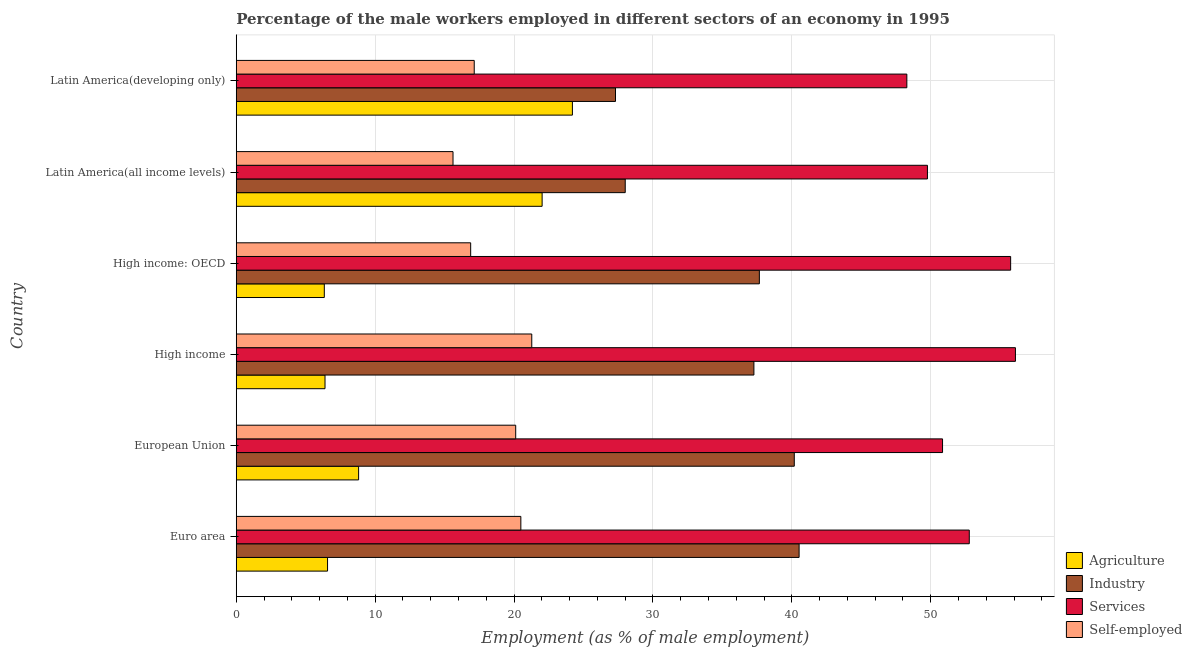Are the number of bars per tick equal to the number of legend labels?
Make the answer very short. Yes. Are the number of bars on each tick of the Y-axis equal?
Keep it short and to the point. Yes. How many bars are there on the 2nd tick from the top?
Give a very brief answer. 4. What is the label of the 1st group of bars from the top?
Your answer should be very brief. Latin America(developing only). In how many cases, is the number of bars for a given country not equal to the number of legend labels?
Your answer should be very brief. 0. What is the percentage of male workers in services in High income: OECD?
Your response must be concise. 55.76. Across all countries, what is the maximum percentage of self employed male workers?
Make the answer very short. 21.28. Across all countries, what is the minimum percentage of male workers in industry?
Give a very brief answer. 27.31. In which country was the percentage of male workers in industry maximum?
Your response must be concise. Euro area. In which country was the percentage of self employed male workers minimum?
Your answer should be very brief. Latin America(all income levels). What is the total percentage of male workers in services in the graph?
Keep it short and to the point. 313.54. What is the difference between the percentage of male workers in industry in High income: OECD and that in Latin America(all income levels)?
Offer a very short reply. 9.66. What is the difference between the percentage of male workers in industry in High income: OECD and the percentage of self employed male workers in Latin America(all income levels)?
Offer a terse response. 22.06. What is the average percentage of male workers in services per country?
Provide a succinct answer. 52.26. What is the difference between the percentage of male workers in services and percentage of male workers in agriculture in Euro area?
Make the answer very short. 46.21. In how many countries, is the percentage of male workers in agriculture greater than 8 %?
Provide a succinct answer. 3. What is the ratio of the percentage of self employed male workers in Euro area to that in Latin America(all income levels)?
Your answer should be compact. 1.31. Is the percentage of self employed male workers in European Union less than that in Latin America(all income levels)?
Provide a short and direct response. No. Is the difference between the percentage of self employed male workers in High income and High income: OECD greater than the difference between the percentage of male workers in agriculture in High income and High income: OECD?
Give a very brief answer. Yes. What is the difference between the highest and the second highest percentage of self employed male workers?
Keep it short and to the point. 0.79. What is the difference between the highest and the lowest percentage of male workers in industry?
Give a very brief answer. 13.22. Is the sum of the percentage of male workers in agriculture in High income: OECD and Latin America(all income levels) greater than the maximum percentage of male workers in industry across all countries?
Offer a very short reply. No. What does the 2nd bar from the top in Euro area represents?
Your answer should be compact. Services. What does the 1st bar from the bottom in High income represents?
Your answer should be compact. Agriculture. How many bars are there?
Give a very brief answer. 24. Are all the bars in the graph horizontal?
Your response must be concise. Yes. How many countries are there in the graph?
Your answer should be very brief. 6. Does the graph contain grids?
Provide a succinct answer. Yes. How many legend labels are there?
Provide a short and direct response. 4. What is the title of the graph?
Give a very brief answer. Percentage of the male workers employed in different sectors of an economy in 1995. Does "International Monetary Fund" appear as one of the legend labels in the graph?
Your response must be concise. No. What is the label or title of the X-axis?
Make the answer very short. Employment (as % of male employment). What is the Employment (as % of male employment) of Agriculture in Euro area?
Provide a short and direct response. 6.57. What is the Employment (as % of male employment) of Industry in Euro area?
Your answer should be compact. 40.53. What is the Employment (as % of male employment) of Services in Euro area?
Offer a terse response. 52.78. What is the Employment (as % of male employment) in Self-employed in Euro area?
Provide a short and direct response. 20.49. What is the Employment (as % of male employment) of Agriculture in European Union?
Provide a succinct answer. 8.81. What is the Employment (as % of male employment) of Industry in European Union?
Give a very brief answer. 40.18. What is the Employment (as % of male employment) in Services in European Union?
Make the answer very short. 50.85. What is the Employment (as % of male employment) in Self-employed in European Union?
Your answer should be very brief. 20.12. What is the Employment (as % of male employment) in Agriculture in High income?
Offer a terse response. 6.39. What is the Employment (as % of male employment) in Industry in High income?
Provide a succinct answer. 37.27. What is the Employment (as % of male employment) in Services in High income?
Your response must be concise. 56.1. What is the Employment (as % of male employment) of Self-employed in High income?
Give a very brief answer. 21.28. What is the Employment (as % of male employment) of Agriculture in High income: OECD?
Ensure brevity in your answer.  6.34. What is the Employment (as % of male employment) of Industry in High income: OECD?
Keep it short and to the point. 37.66. What is the Employment (as % of male employment) of Services in High income: OECD?
Keep it short and to the point. 55.76. What is the Employment (as % of male employment) of Self-employed in High income: OECD?
Offer a very short reply. 16.88. What is the Employment (as % of male employment) of Agriculture in Latin America(all income levels)?
Offer a terse response. 22.02. What is the Employment (as % of male employment) of Industry in Latin America(all income levels)?
Keep it short and to the point. 28.01. What is the Employment (as % of male employment) of Services in Latin America(all income levels)?
Give a very brief answer. 49.77. What is the Employment (as % of male employment) in Self-employed in Latin America(all income levels)?
Offer a terse response. 15.61. What is the Employment (as % of male employment) in Agriculture in Latin America(developing only)?
Provide a succinct answer. 24.2. What is the Employment (as % of male employment) in Industry in Latin America(developing only)?
Give a very brief answer. 27.31. What is the Employment (as % of male employment) of Services in Latin America(developing only)?
Your response must be concise. 48.28. What is the Employment (as % of male employment) of Self-employed in Latin America(developing only)?
Give a very brief answer. 17.14. Across all countries, what is the maximum Employment (as % of male employment) in Agriculture?
Offer a terse response. 24.2. Across all countries, what is the maximum Employment (as % of male employment) in Industry?
Your answer should be very brief. 40.53. Across all countries, what is the maximum Employment (as % of male employment) of Services?
Offer a terse response. 56.1. Across all countries, what is the maximum Employment (as % of male employment) of Self-employed?
Ensure brevity in your answer.  21.28. Across all countries, what is the minimum Employment (as % of male employment) of Agriculture?
Your response must be concise. 6.34. Across all countries, what is the minimum Employment (as % of male employment) of Industry?
Your answer should be very brief. 27.31. Across all countries, what is the minimum Employment (as % of male employment) of Services?
Your response must be concise. 48.28. Across all countries, what is the minimum Employment (as % of male employment) in Self-employed?
Provide a succinct answer. 15.61. What is the total Employment (as % of male employment) of Agriculture in the graph?
Make the answer very short. 74.34. What is the total Employment (as % of male employment) of Industry in the graph?
Give a very brief answer. 210.96. What is the total Employment (as % of male employment) in Services in the graph?
Make the answer very short. 313.54. What is the total Employment (as % of male employment) in Self-employed in the graph?
Provide a short and direct response. 111.51. What is the difference between the Employment (as % of male employment) of Agriculture in Euro area and that in European Union?
Ensure brevity in your answer.  -2.24. What is the difference between the Employment (as % of male employment) of Industry in Euro area and that in European Union?
Provide a succinct answer. 0.35. What is the difference between the Employment (as % of male employment) in Services in Euro area and that in European Union?
Keep it short and to the point. 1.93. What is the difference between the Employment (as % of male employment) of Self-employed in Euro area and that in European Union?
Provide a succinct answer. 0.37. What is the difference between the Employment (as % of male employment) in Agriculture in Euro area and that in High income?
Your answer should be compact. 0.18. What is the difference between the Employment (as % of male employment) of Industry in Euro area and that in High income?
Offer a terse response. 3.25. What is the difference between the Employment (as % of male employment) of Services in Euro area and that in High income?
Make the answer very short. -3.32. What is the difference between the Employment (as % of male employment) in Self-employed in Euro area and that in High income?
Ensure brevity in your answer.  -0.79. What is the difference between the Employment (as % of male employment) in Agriculture in Euro area and that in High income: OECD?
Make the answer very short. 0.23. What is the difference between the Employment (as % of male employment) of Industry in Euro area and that in High income: OECD?
Offer a very short reply. 2.86. What is the difference between the Employment (as % of male employment) of Services in Euro area and that in High income: OECD?
Make the answer very short. -2.98. What is the difference between the Employment (as % of male employment) in Self-employed in Euro area and that in High income: OECD?
Your answer should be compact. 3.61. What is the difference between the Employment (as % of male employment) in Agriculture in Euro area and that in Latin America(all income levels)?
Ensure brevity in your answer.  -15.45. What is the difference between the Employment (as % of male employment) of Industry in Euro area and that in Latin America(all income levels)?
Your answer should be compact. 12.52. What is the difference between the Employment (as % of male employment) in Services in Euro area and that in Latin America(all income levels)?
Make the answer very short. 3.01. What is the difference between the Employment (as % of male employment) in Self-employed in Euro area and that in Latin America(all income levels)?
Offer a very short reply. 4.88. What is the difference between the Employment (as % of male employment) in Agriculture in Euro area and that in Latin America(developing only)?
Provide a succinct answer. -17.63. What is the difference between the Employment (as % of male employment) of Industry in Euro area and that in Latin America(developing only)?
Make the answer very short. 13.22. What is the difference between the Employment (as % of male employment) in Services in Euro area and that in Latin America(developing only)?
Keep it short and to the point. 4.5. What is the difference between the Employment (as % of male employment) of Self-employed in Euro area and that in Latin America(developing only)?
Your answer should be compact. 3.36. What is the difference between the Employment (as % of male employment) of Agriculture in European Union and that in High income?
Ensure brevity in your answer.  2.42. What is the difference between the Employment (as % of male employment) in Industry in European Union and that in High income?
Make the answer very short. 2.91. What is the difference between the Employment (as % of male employment) in Services in European Union and that in High income?
Your answer should be compact. -5.25. What is the difference between the Employment (as % of male employment) of Self-employed in European Union and that in High income?
Your answer should be compact. -1.16. What is the difference between the Employment (as % of male employment) of Agriculture in European Union and that in High income: OECD?
Your answer should be very brief. 2.47. What is the difference between the Employment (as % of male employment) in Industry in European Union and that in High income: OECD?
Your answer should be compact. 2.52. What is the difference between the Employment (as % of male employment) of Services in European Union and that in High income: OECD?
Offer a very short reply. -4.9. What is the difference between the Employment (as % of male employment) in Self-employed in European Union and that in High income: OECD?
Your answer should be very brief. 3.24. What is the difference between the Employment (as % of male employment) in Agriculture in European Union and that in Latin America(all income levels)?
Ensure brevity in your answer.  -13.21. What is the difference between the Employment (as % of male employment) in Industry in European Union and that in Latin America(all income levels)?
Give a very brief answer. 12.17. What is the difference between the Employment (as % of male employment) in Services in European Union and that in Latin America(all income levels)?
Provide a succinct answer. 1.09. What is the difference between the Employment (as % of male employment) of Self-employed in European Union and that in Latin America(all income levels)?
Provide a succinct answer. 4.51. What is the difference between the Employment (as % of male employment) in Agriculture in European Union and that in Latin America(developing only)?
Offer a terse response. -15.39. What is the difference between the Employment (as % of male employment) in Industry in European Union and that in Latin America(developing only)?
Make the answer very short. 12.87. What is the difference between the Employment (as % of male employment) in Services in European Union and that in Latin America(developing only)?
Keep it short and to the point. 2.57. What is the difference between the Employment (as % of male employment) in Self-employed in European Union and that in Latin America(developing only)?
Make the answer very short. 2.99. What is the difference between the Employment (as % of male employment) in Agriculture in High income and that in High income: OECD?
Your answer should be compact. 0.05. What is the difference between the Employment (as % of male employment) of Industry in High income and that in High income: OECD?
Offer a terse response. -0.39. What is the difference between the Employment (as % of male employment) in Services in High income and that in High income: OECD?
Ensure brevity in your answer.  0.35. What is the difference between the Employment (as % of male employment) of Self-employed in High income and that in High income: OECD?
Keep it short and to the point. 4.4. What is the difference between the Employment (as % of male employment) of Agriculture in High income and that in Latin America(all income levels)?
Give a very brief answer. -15.63. What is the difference between the Employment (as % of male employment) in Industry in High income and that in Latin America(all income levels)?
Your response must be concise. 9.26. What is the difference between the Employment (as % of male employment) in Services in High income and that in Latin America(all income levels)?
Give a very brief answer. 6.34. What is the difference between the Employment (as % of male employment) of Self-employed in High income and that in Latin America(all income levels)?
Ensure brevity in your answer.  5.67. What is the difference between the Employment (as % of male employment) of Agriculture in High income and that in Latin America(developing only)?
Provide a short and direct response. -17.81. What is the difference between the Employment (as % of male employment) of Industry in High income and that in Latin America(developing only)?
Ensure brevity in your answer.  9.97. What is the difference between the Employment (as % of male employment) of Services in High income and that in Latin America(developing only)?
Ensure brevity in your answer.  7.82. What is the difference between the Employment (as % of male employment) of Self-employed in High income and that in Latin America(developing only)?
Give a very brief answer. 4.14. What is the difference between the Employment (as % of male employment) of Agriculture in High income: OECD and that in Latin America(all income levels)?
Your answer should be compact. -15.68. What is the difference between the Employment (as % of male employment) in Industry in High income: OECD and that in Latin America(all income levels)?
Offer a terse response. 9.66. What is the difference between the Employment (as % of male employment) in Services in High income: OECD and that in Latin America(all income levels)?
Provide a succinct answer. 5.99. What is the difference between the Employment (as % of male employment) of Self-employed in High income: OECD and that in Latin America(all income levels)?
Offer a terse response. 1.27. What is the difference between the Employment (as % of male employment) in Agriculture in High income: OECD and that in Latin America(developing only)?
Your response must be concise. -17.86. What is the difference between the Employment (as % of male employment) in Industry in High income: OECD and that in Latin America(developing only)?
Ensure brevity in your answer.  10.36. What is the difference between the Employment (as % of male employment) of Services in High income: OECD and that in Latin America(developing only)?
Offer a terse response. 7.47. What is the difference between the Employment (as % of male employment) of Self-employed in High income: OECD and that in Latin America(developing only)?
Make the answer very short. -0.26. What is the difference between the Employment (as % of male employment) in Agriculture in Latin America(all income levels) and that in Latin America(developing only)?
Offer a terse response. -2.18. What is the difference between the Employment (as % of male employment) in Industry in Latin America(all income levels) and that in Latin America(developing only)?
Make the answer very short. 0.7. What is the difference between the Employment (as % of male employment) in Services in Latin America(all income levels) and that in Latin America(developing only)?
Offer a very short reply. 1.48. What is the difference between the Employment (as % of male employment) of Self-employed in Latin America(all income levels) and that in Latin America(developing only)?
Provide a short and direct response. -1.53. What is the difference between the Employment (as % of male employment) of Agriculture in Euro area and the Employment (as % of male employment) of Industry in European Union?
Provide a short and direct response. -33.61. What is the difference between the Employment (as % of male employment) in Agriculture in Euro area and the Employment (as % of male employment) in Services in European Union?
Offer a very short reply. -44.28. What is the difference between the Employment (as % of male employment) of Agriculture in Euro area and the Employment (as % of male employment) of Self-employed in European Union?
Keep it short and to the point. -13.55. What is the difference between the Employment (as % of male employment) of Industry in Euro area and the Employment (as % of male employment) of Services in European Union?
Keep it short and to the point. -10.33. What is the difference between the Employment (as % of male employment) in Industry in Euro area and the Employment (as % of male employment) in Self-employed in European Union?
Ensure brevity in your answer.  20.41. What is the difference between the Employment (as % of male employment) in Services in Euro area and the Employment (as % of male employment) in Self-employed in European Union?
Ensure brevity in your answer.  32.66. What is the difference between the Employment (as % of male employment) of Agriculture in Euro area and the Employment (as % of male employment) of Industry in High income?
Make the answer very short. -30.7. What is the difference between the Employment (as % of male employment) in Agriculture in Euro area and the Employment (as % of male employment) in Services in High income?
Offer a very short reply. -49.53. What is the difference between the Employment (as % of male employment) in Agriculture in Euro area and the Employment (as % of male employment) in Self-employed in High income?
Keep it short and to the point. -14.7. What is the difference between the Employment (as % of male employment) in Industry in Euro area and the Employment (as % of male employment) in Services in High income?
Provide a short and direct response. -15.58. What is the difference between the Employment (as % of male employment) in Industry in Euro area and the Employment (as % of male employment) in Self-employed in High income?
Your response must be concise. 19.25. What is the difference between the Employment (as % of male employment) in Services in Euro area and the Employment (as % of male employment) in Self-employed in High income?
Offer a terse response. 31.5. What is the difference between the Employment (as % of male employment) of Agriculture in Euro area and the Employment (as % of male employment) of Industry in High income: OECD?
Your response must be concise. -31.09. What is the difference between the Employment (as % of male employment) in Agriculture in Euro area and the Employment (as % of male employment) in Services in High income: OECD?
Your response must be concise. -49.18. What is the difference between the Employment (as % of male employment) in Agriculture in Euro area and the Employment (as % of male employment) in Self-employed in High income: OECD?
Your answer should be very brief. -10.3. What is the difference between the Employment (as % of male employment) of Industry in Euro area and the Employment (as % of male employment) of Services in High income: OECD?
Your answer should be very brief. -15.23. What is the difference between the Employment (as % of male employment) in Industry in Euro area and the Employment (as % of male employment) in Self-employed in High income: OECD?
Provide a succinct answer. 23.65. What is the difference between the Employment (as % of male employment) of Services in Euro area and the Employment (as % of male employment) of Self-employed in High income: OECD?
Offer a terse response. 35.9. What is the difference between the Employment (as % of male employment) in Agriculture in Euro area and the Employment (as % of male employment) in Industry in Latin America(all income levels)?
Offer a terse response. -21.43. What is the difference between the Employment (as % of male employment) of Agriculture in Euro area and the Employment (as % of male employment) of Services in Latin America(all income levels)?
Your response must be concise. -43.19. What is the difference between the Employment (as % of male employment) in Agriculture in Euro area and the Employment (as % of male employment) in Self-employed in Latin America(all income levels)?
Your answer should be compact. -9.03. What is the difference between the Employment (as % of male employment) in Industry in Euro area and the Employment (as % of male employment) in Services in Latin America(all income levels)?
Provide a short and direct response. -9.24. What is the difference between the Employment (as % of male employment) of Industry in Euro area and the Employment (as % of male employment) of Self-employed in Latin America(all income levels)?
Offer a terse response. 24.92. What is the difference between the Employment (as % of male employment) of Services in Euro area and the Employment (as % of male employment) of Self-employed in Latin America(all income levels)?
Your answer should be compact. 37.17. What is the difference between the Employment (as % of male employment) in Agriculture in Euro area and the Employment (as % of male employment) in Industry in Latin America(developing only)?
Keep it short and to the point. -20.73. What is the difference between the Employment (as % of male employment) in Agriculture in Euro area and the Employment (as % of male employment) in Services in Latin America(developing only)?
Provide a short and direct response. -41.71. What is the difference between the Employment (as % of male employment) in Agriculture in Euro area and the Employment (as % of male employment) in Self-employed in Latin America(developing only)?
Offer a very short reply. -10.56. What is the difference between the Employment (as % of male employment) in Industry in Euro area and the Employment (as % of male employment) in Services in Latin America(developing only)?
Your answer should be very brief. -7.76. What is the difference between the Employment (as % of male employment) in Industry in Euro area and the Employment (as % of male employment) in Self-employed in Latin America(developing only)?
Offer a terse response. 23.39. What is the difference between the Employment (as % of male employment) in Services in Euro area and the Employment (as % of male employment) in Self-employed in Latin America(developing only)?
Offer a terse response. 35.64. What is the difference between the Employment (as % of male employment) in Agriculture in European Union and the Employment (as % of male employment) in Industry in High income?
Make the answer very short. -28.46. What is the difference between the Employment (as % of male employment) of Agriculture in European Union and the Employment (as % of male employment) of Services in High income?
Your answer should be very brief. -47.29. What is the difference between the Employment (as % of male employment) of Agriculture in European Union and the Employment (as % of male employment) of Self-employed in High income?
Ensure brevity in your answer.  -12.47. What is the difference between the Employment (as % of male employment) in Industry in European Union and the Employment (as % of male employment) in Services in High income?
Give a very brief answer. -15.92. What is the difference between the Employment (as % of male employment) in Industry in European Union and the Employment (as % of male employment) in Self-employed in High income?
Give a very brief answer. 18.9. What is the difference between the Employment (as % of male employment) of Services in European Union and the Employment (as % of male employment) of Self-employed in High income?
Your answer should be very brief. 29.58. What is the difference between the Employment (as % of male employment) in Agriculture in European Union and the Employment (as % of male employment) in Industry in High income: OECD?
Your response must be concise. -28.85. What is the difference between the Employment (as % of male employment) in Agriculture in European Union and the Employment (as % of male employment) in Services in High income: OECD?
Make the answer very short. -46.95. What is the difference between the Employment (as % of male employment) in Agriculture in European Union and the Employment (as % of male employment) in Self-employed in High income: OECD?
Keep it short and to the point. -8.07. What is the difference between the Employment (as % of male employment) in Industry in European Union and the Employment (as % of male employment) in Services in High income: OECD?
Offer a very short reply. -15.58. What is the difference between the Employment (as % of male employment) in Industry in European Union and the Employment (as % of male employment) in Self-employed in High income: OECD?
Ensure brevity in your answer.  23.3. What is the difference between the Employment (as % of male employment) in Services in European Union and the Employment (as % of male employment) in Self-employed in High income: OECD?
Make the answer very short. 33.98. What is the difference between the Employment (as % of male employment) of Agriculture in European Union and the Employment (as % of male employment) of Industry in Latin America(all income levels)?
Your response must be concise. -19.2. What is the difference between the Employment (as % of male employment) in Agriculture in European Union and the Employment (as % of male employment) in Services in Latin America(all income levels)?
Offer a terse response. -40.96. What is the difference between the Employment (as % of male employment) of Agriculture in European Union and the Employment (as % of male employment) of Self-employed in Latin America(all income levels)?
Provide a short and direct response. -6.8. What is the difference between the Employment (as % of male employment) of Industry in European Union and the Employment (as % of male employment) of Services in Latin America(all income levels)?
Offer a very short reply. -9.59. What is the difference between the Employment (as % of male employment) of Industry in European Union and the Employment (as % of male employment) of Self-employed in Latin America(all income levels)?
Offer a terse response. 24.57. What is the difference between the Employment (as % of male employment) of Services in European Union and the Employment (as % of male employment) of Self-employed in Latin America(all income levels)?
Ensure brevity in your answer.  35.25. What is the difference between the Employment (as % of male employment) of Agriculture in European Union and the Employment (as % of male employment) of Industry in Latin America(developing only)?
Make the answer very short. -18.5. What is the difference between the Employment (as % of male employment) of Agriculture in European Union and the Employment (as % of male employment) of Services in Latin America(developing only)?
Ensure brevity in your answer.  -39.47. What is the difference between the Employment (as % of male employment) of Agriculture in European Union and the Employment (as % of male employment) of Self-employed in Latin America(developing only)?
Make the answer very short. -8.33. What is the difference between the Employment (as % of male employment) in Industry in European Union and the Employment (as % of male employment) in Services in Latin America(developing only)?
Your response must be concise. -8.1. What is the difference between the Employment (as % of male employment) in Industry in European Union and the Employment (as % of male employment) in Self-employed in Latin America(developing only)?
Provide a short and direct response. 23.04. What is the difference between the Employment (as % of male employment) in Services in European Union and the Employment (as % of male employment) in Self-employed in Latin America(developing only)?
Offer a terse response. 33.72. What is the difference between the Employment (as % of male employment) in Agriculture in High income and the Employment (as % of male employment) in Industry in High income: OECD?
Your answer should be very brief. -31.27. What is the difference between the Employment (as % of male employment) in Agriculture in High income and the Employment (as % of male employment) in Services in High income: OECD?
Keep it short and to the point. -49.37. What is the difference between the Employment (as % of male employment) of Agriculture in High income and the Employment (as % of male employment) of Self-employed in High income: OECD?
Keep it short and to the point. -10.49. What is the difference between the Employment (as % of male employment) of Industry in High income and the Employment (as % of male employment) of Services in High income: OECD?
Your answer should be very brief. -18.49. What is the difference between the Employment (as % of male employment) in Industry in High income and the Employment (as % of male employment) in Self-employed in High income: OECD?
Keep it short and to the point. 20.39. What is the difference between the Employment (as % of male employment) in Services in High income and the Employment (as % of male employment) in Self-employed in High income: OECD?
Your answer should be very brief. 39.22. What is the difference between the Employment (as % of male employment) in Agriculture in High income and the Employment (as % of male employment) in Industry in Latin America(all income levels)?
Offer a terse response. -21.62. What is the difference between the Employment (as % of male employment) of Agriculture in High income and the Employment (as % of male employment) of Services in Latin America(all income levels)?
Provide a succinct answer. -43.38. What is the difference between the Employment (as % of male employment) in Agriculture in High income and the Employment (as % of male employment) in Self-employed in Latin America(all income levels)?
Your answer should be compact. -9.22. What is the difference between the Employment (as % of male employment) of Industry in High income and the Employment (as % of male employment) of Services in Latin America(all income levels)?
Make the answer very short. -12.49. What is the difference between the Employment (as % of male employment) in Industry in High income and the Employment (as % of male employment) in Self-employed in Latin America(all income levels)?
Your response must be concise. 21.66. What is the difference between the Employment (as % of male employment) in Services in High income and the Employment (as % of male employment) in Self-employed in Latin America(all income levels)?
Make the answer very short. 40.5. What is the difference between the Employment (as % of male employment) of Agriculture in High income and the Employment (as % of male employment) of Industry in Latin America(developing only)?
Keep it short and to the point. -20.92. What is the difference between the Employment (as % of male employment) in Agriculture in High income and the Employment (as % of male employment) in Services in Latin America(developing only)?
Provide a short and direct response. -41.89. What is the difference between the Employment (as % of male employment) of Agriculture in High income and the Employment (as % of male employment) of Self-employed in Latin America(developing only)?
Give a very brief answer. -10.74. What is the difference between the Employment (as % of male employment) of Industry in High income and the Employment (as % of male employment) of Services in Latin America(developing only)?
Give a very brief answer. -11.01. What is the difference between the Employment (as % of male employment) of Industry in High income and the Employment (as % of male employment) of Self-employed in Latin America(developing only)?
Keep it short and to the point. 20.14. What is the difference between the Employment (as % of male employment) of Services in High income and the Employment (as % of male employment) of Self-employed in Latin America(developing only)?
Ensure brevity in your answer.  38.97. What is the difference between the Employment (as % of male employment) in Agriculture in High income: OECD and the Employment (as % of male employment) in Industry in Latin America(all income levels)?
Ensure brevity in your answer.  -21.67. What is the difference between the Employment (as % of male employment) in Agriculture in High income: OECD and the Employment (as % of male employment) in Services in Latin America(all income levels)?
Ensure brevity in your answer.  -43.43. What is the difference between the Employment (as % of male employment) in Agriculture in High income: OECD and the Employment (as % of male employment) in Self-employed in Latin America(all income levels)?
Offer a terse response. -9.27. What is the difference between the Employment (as % of male employment) of Industry in High income: OECD and the Employment (as % of male employment) of Services in Latin America(all income levels)?
Provide a succinct answer. -12.1. What is the difference between the Employment (as % of male employment) in Industry in High income: OECD and the Employment (as % of male employment) in Self-employed in Latin America(all income levels)?
Your response must be concise. 22.06. What is the difference between the Employment (as % of male employment) of Services in High income: OECD and the Employment (as % of male employment) of Self-employed in Latin America(all income levels)?
Provide a succinct answer. 40.15. What is the difference between the Employment (as % of male employment) in Agriculture in High income: OECD and the Employment (as % of male employment) in Industry in Latin America(developing only)?
Ensure brevity in your answer.  -20.97. What is the difference between the Employment (as % of male employment) in Agriculture in High income: OECD and the Employment (as % of male employment) in Services in Latin America(developing only)?
Offer a terse response. -41.94. What is the difference between the Employment (as % of male employment) in Agriculture in High income: OECD and the Employment (as % of male employment) in Self-employed in Latin America(developing only)?
Make the answer very short. -10.8. What is the difference between the Employment (as % of male employment) in Industry in High income: OECD and the Employment (as % of male employment) in Services in Latin America(developing only)?
Your answer should be compact. -10.62. What is the difference between the Employment (as % of male employment) in Industry in High income: OECD and the Employment (as % of male employment) in Self-employed in Latin America(developing only)?
Give a very brief answer. 20.53. What is the difference between the Employment (as % of male employment) of Services in High income: OECD and the Employment (as % of male employment) of Self-employed in Latin America(developing only)?
Your answer should be very brief. 38.62. What is the difference between the Employment (as % of male employment) in Agriculture in Latin America(all income levels) and the Employment (as % of male employment) in Industry in Latin America(developing only)?
Make the answer very short. -5.28. What is the difference between the Employment (as % of male employment) in Agriculture in Latin America(all income levels) and the Employment (as % of male employment) in Services in Latin America(developing only)?
Offer a terse response. -26.26. What is the difference between the Employment (as % of male employment) of Agriculture in Latin America(all income levels) and the Employment (as % of male employment) of Self-employed in Latin America(developing only)?
Offer a terse response. 4.89. What is the difference between the Employment (as % of male employment) in Industry in Latin America(all income levels) and the Employment (as % of male employment) in Services in Latin America(developing only)?
Your response must be concise. -20.28. What is the difference between the Employment (as % of male employment) in Industry in Latin America(all income levels) and the Employment (as % of male employment) in Self-employed in Latin America(developing only)?
Your answer should be compact. 10.87. What is the difference between the Employment (as % of male employment) in Services in Latin America(all income levels) and the Employment (as % of male employment) in Self-employed in Latin America(developing only)?
Ensure brevity in your answer.  32.63. What is the average Employment (as % of male employment) in Agriculture per country?
Offer a very short reply. 12.39. What is the average Employment (as % of male employment) in Industry per country?
Offer a terse response. 35.16. What is the average Employment (as % of male employment) of Services per country?
Your response must be concise. 52.26. What is the average Employment (as % of male employment) in Self-employed per country?
Keep it short and to the point. 18.58. What is the difference between the Employment (as % of male employment) of Agriculture and Employment (as % of male employment) of Industry in Euro area?
Offer a terse response. -33.95. What is the difference between the Employment (as % of male employment) in Agriculture and Employment (as % of male employment) in Services in Euro area?
Offer a terse response. -46.21. What is the difference between the Employment (as % of male employment) of Agriculture and Employment (as % of male employment) of Self-employed in Euro area?
Offer a very short reply. -13.92. What is the difference between the Employment (as % of male employment) of Industry and Employment (as % of male employment) of Services in Euro area?
Provide a succinct answer. -12.25. What is the difference between the Employment (as % of male employment) in Industry and Employment (as % of male employment) in Self-employed in Euro area?
Give a very brief answer. 20.04. What is the difference between the Employment (as % of male employment) in Services and Employment (as % of male employment) in Self-employed in Euro area?
Your response must be concise. 32.29. What is the difference between the Employment (as % of male employment) in Agriculture and Employment (as % of male employment) in Industry in European Union?
Keep it short and to the point. -31.37. What is the difference between the Employment (as % of male employment) of Agriculture and Employment (as % of male employment) of Services in European Union?
Ensure brevity in your answer.  -42.04. What is the difference between the Employment (as % of male employment) in Agriculture and Employment (as % of male employment) in Self-employed in European Union?
Provide a succinct answer. -11.31. What is the difference between the Employment (as % of male employment) in Industry and Employment (as % of male employment) in Services in European Union?
Your answer should be compact. -10.68. What is the difference between the Employment (as % of male employment) of Industry and Employment (as % of male employment) of Self-employed in European Union?
Keep it short and to the point. 20.06. What is the difference between the Employment (as % of male employment) in Services and Employment (as % of male employment) in Self-employed in European Union?
Your answer should be very brief. 30.73. What is the difference between the Employment (as % of male employment) in Agriculture and Employment (as % of male employment) in Industry in High income?
Ensure brevity in your answer.  -30.88. What is the difference between the Employment (as % of male employment) in Agriculture and Employment (as % of male employment) in Services in High income?
Your response must be concise. -49.71. What is the difference between the Employment (as % of male employment) of Agriculture and Employment (as % of male employment) of Self-employed in High income?
Give a very brief answer. -14.89. What is the difference between the Employment (as % of male employment) of Industry and Employment (as % of male employment) of Services in High income?
Provide a short and direct response. -18.83. What is the difference between the Employment (as % of male employment) in Industry and Employment (as % of male employment) in Self-employed in High income?
Ensure brevity in your answer.  15.99. What is the difference between the Employment (as % of male employment) of Services and Employment (as % of male employment) of Self-employed in High income?
Your answer should be compact. 34.82. What is the difference between the Employment (as % of male employment) of Agriculture and Employment (as % of male employment) of Industry in High income: OECD?
Make the answer very short. -31.32. What is the difference between the Employment (as % of male employment) in Agriculture and Employment (as % of male employment) in Services in High income: OECD?
Keep it short and to the point. -49.42. What is the difference between the Employment (as % of male employment) of Agriculture and Employment (as % of male employment) of Self-employed in High income: OECD?
Ensure brevity in your answer.  -10.54. What is the difference between the Employment (as % of male employment) of Industry and Employment (as % of male employment) of Services in High income: OECD?
Your answer should be compact. -18.09. What is the difference between the Employment (as % of male employment) in Industry and Employment (as % of male employment) in Self-employed in High income: OECD?
Offer a very short reply. 20.79. What is the difference between the Employment (as % of male employment) in Services and Employment (as % of male employment) in Self-employed in High income: OECD?
Your answer should be very brief. 38.88. What is the difference between the Employment (as % of male employment) of Agriculture and Employment (as % of male employment) of Industry in Latin America(all income levels)?
Ensure brevity in your answer.  -5.98. What is the difference between the Employment (as % of male employment) in Agriculture and Employment (as % of male employment) in Services in Latin America(all income levels)?
Your answer should be very brief. -27.74. What is the difference between the Employment (as % of male employment) in Agriculture and Employment (as % of male employment) in Self-employed in Latin America(all income levels)?
Your answer should be compact. 6.42. What is the difference between the Employment (as % of male employment) of Industry and Employment (as % of male employment) of Services in Latin America(all income levels)?
Provide a short and direct response. -21.76. What is the difference between the Employment (as % of male employment) of Industry and Employment (as % of male employment) of Self-employed in Latin America(all income levels)?
Your answer should be compact. 12.4. What is the difference between the Employment (as % of male employment) in Services and Employment (as % of male employment) in Self-employed in Latin America(all income levels)?
Offer a very short reply. 34.16. What is the difference between the Employment (as % of male employment) of Agriculture and Employment (as % of male employment) of Industry in Latin America(developing only)?
Your answer should be compact. -3.1. What is the difference between the Employment (as % of male employment) in Agriculture and Employment (as % of male employment) in Services in Latin America(developing only)?
Offer a very short reply. -24.08. What is the difference between the Employment (as % of male employment) in Agriculture and Employment (as % of male employment) in Self-employed in Latin America(developing only)?
Ensure brevity in your answer.  7.07. What is the difference between the Employment (as % of male employment) in Industry and Employment (as % of male employment) in Services in Latin America(developing only)?
Keep it short and to the point. -20.98. What is the difference between the Employment (as % of male employment) in Industry and Employment (as % of male employment) in Self-employed in Latin America(developing only)?
Your answer should be very brief. 10.17. What is the difference between the Employment (as % of male employment) of Services and Employment (as % of male employment) of Self-employed in Latin America(developing only)?
Ensure brevity in your answer.  31.15. What is the ratio of the Employment (as % of male employment) in Agriculture in Euro area to that in European Union?
Provide a short and direct response. 0.75. What is the ratio of the Employment (as % of male employment) of Industry in Euro area to that in European Union?
Make the answer very short. 1.01. What is the ratio of the Employment (as % of male employment) in Services in Euro area to that in European Union?
Ensure brevity in your answer.  1.04. What is the ratio of the Employment (as % of male employment) of Self-employed in Euro area to that in European Union?
Your answer should be very brief. 1.02. What is the ratio of the Employment (as % of male employment) in Agriculture in Euro area to that in High income?
Your answer should be very brief. 1.03. What is the ratio of the Employment (as % of male employment) of Industry in Euro area to that in High income?
Give a very brief answer. 1.09. What is the ratio of the Employment (as % of male employment) in Services in Euro area to that in High income?
Give a very brief answer. 0.94. What is the ratio of the Employment (as % of male employment) of Self-employed in Euro area to that in High income?
Give a very brief answer. 0.96. What is the ratio of the Employment (as % of male employment) in Agriculture in Euro area to that in High income: OECD?
Your answer should be compact. 1.04. What is the ratio of the Employment (as % of male employment) of Industry in Euro area to that in High income: OECD?
Keep it short and to the point. 1.08. What is the ratio of the Employment (as % of male employment) in Services in Euro area to that in High income: OECD?
Offer a terse response. 0.95. What is the ratio of the Employment (as % of male employment) of Self-employed in Euro area to that in High income: OECD?
Make the answer very short. 1.21. What is the ratio of the Employment (as % of male employment) of Agriculture in Euro area to that in Latin America(all income levels)?
Provide a short and direct response. 0.3. What is the ratio of the Employment (as % of male employment) of Industry in Euro area to that in Latin America(all income levels)?
Offer a very short reply. 1.45. What is the ratio of the Employment (as % of male employment) of Services in Euro area to that in Latin America(all income levels)?
Your answer should be very brief. 1.06. What is the ratio of the Employment (as % of male employment) in Self-employed in Euro area to that in Latin America(all income levels)?
Keep it short and to the point. 1.31. What is the ratio of the Employment (as % of male employment) in Agriculture in Euro area to that in Latin America(developing only)?
Your response must be concise. 0.27. What is the ratio of the Employment (as % of male employment) of Industry in Euro area to that in Latin America(developing only)?
Provide a succinct answer. 1.48. What is the ratio of the Employment (as % of male employment) in Services in Euro area to that in Latin America(developing only)?
Your answer should be compact. 1.09. What is the ratio of the Employment (as % of male employment) in Self-employed in Euro area to that in Latin America(developing only)?
Your response must be concise. 1.2. What is the ratio of the Employment (as % of male employment) of Agriculture in European Union to that in High income?
Make the answer very short. 1.38. What is the ratio of the Employment (as % of male employment) of Industry in European Union to that in High income?
Your answer should be very brief. 1.08. What is the ratio of the Employment (as % of male employment) in Services in European Union to that in High income?
Make the answer very short. 0.91. What is the ratio of the Employment (as % of male employment) in Self-employed in European Union to that in High income?
Ensure brevity in your answer.  0.95. What is the ratio of the Employment (as % of male employment) in Agriculture in European Union to that in High income: OECD?
Make the answer very short. 1.39. What is the ratio of the Employment (as % of male employment) in Industry in European Union to that in High income: OECD?
Ensure brevity in your answer.  1.07. What is the ratio of the Employment (as % of male employment) in Services in European Union to that in High income: OECD?
Your response must be concise. 0.91. What is the ratio of the Employment (as % of male employment) in Self-employed in European Union to that in High income: OECD?
Your response must be concise. 1.19. What is the ratio of the Employment (as % of male employment) in Industry in European Union to that in Latin America(all income levels)?
Provide a succinct answer. 1.43. What is the ratio of the Employment (as % of male employment) in Services in European Union to that in Latin America(all income levels)?
Your answer should be very brief. 1.02. What is the ratio of the Employment (as % of male employment) in Self-employed in European Union to that in Latin America(all income levels)?
Provide a short and direct response. 1.29. What is the ratio of the Employment (as % of male employment) in Agriculture in European Union to that in Latin America(developing only)?
Provide a succinct answer. 0.36. What is the ratio of the Employment (as % of male employment) in Industry in European Union to that in Latin America(developing only)?
Keep it short and to the point. 1.47. What is the ratio of the Employment (as % of male employment) in Services in European Union to that in Latin America(developing only)?
Your response must be concise. 1.05. What is the ratio of the Employment (as % of male employment) of Self-employed in European Union to that in Latin America(developing only)?
Ensure brevity in your answer.  1.17. What is the ratio of the Employment (as % of male employment) in Agriculture in High income to that in High income: OECD?
Give a very brief answer. 1.01. What is the ratio of the Employment (as % of male employment) in Industry in High income to that in High income: OECD?
Your answer should be very brief. 0.99. What is the ratio of the Employment (as % of male employment) of Self-employed in High income to that in High income: OECD?
Your response must be concise. 1.26. What is the ratio of the Employment (as % of male employment) in Agriculture in High income to that in Latin America(all income levels)?
Offer a very short reply. 0.29. What is the ratio of the Employment (as % of male employment) of Industry in High income to that in Latin America(all income levels)?
Your answer should be very brief. 1.33. What is the ratio of the Employment (as % of male employment) in Services in High income to that in Latin America(all income levels)?
Offer a terse response. 1.13. What is the ratio of the Employment (as % of male employment) in Self-employed in High income to that in Latin America(all income levels)?
Your answer should be compact. 1.36. What is the ratio of the Employment (as % of male employment) in Agriculture in High income to that in Latin America(developing only)?
Provide a succinct answer. 0.26. What is the ratio of the Employment (as % of male employment) in Industry in High income to that in Latin America(developing only)?
Your response must be concise. 1.36. What is the ratio of the Employment (as % of male employment) of Services in High income to that in Latin America(developing only)?
Your answer should be very brief. 1.16. What is the ratio of the Employment (as % of male employment) of Self-employed in High income to that in Latin America(developing only)?
Offer a very short reply. 1.24. What is the ratio of the Employment (as % of male employment) in Agriculture in High income: OECD to that in Latin America(all income levels)?
Provide a short and direct response. 0.29. What is the ratio of the Employment (as % of male employment) in Industry in High income: OECD to that in Latin America(all income levels)?
Your answer should be compact. 1.34. What is the ratio of the Employment (as % of male employment) in Services in High income: OECD to that in Latin America(all income levels)?
Your answer should be compact. 1.12. What is the ratio of the Employment (as % of male employment) in Self-employed in High income: OECD to that in Latin America(all income levels)?
Your response must be concise. 1.08. What is the ratio of the Employment (as % of male employment) of Agriculture in High income: OECD to that in Latin America(developing only)?
Keep it short and to the point. 0.26. What is the ratio of the Employment (as % of male employment) in Industry in High income: OECD to that in Latin America(developing only)?
Offer a terse response. 1.38. What is the ratio of the Employment (as % of male employment) in Services in High income: OECD to that in Latin America(developing only)?
Provide a succinct answer. 1.15. What is the ratio of the Employment (as % of male employment) of Self-employed in High income: OECD to that in Latin America(developing only)?
Offer a very short reply. 0.98. What is the ratio of the Employment (as % of male employment) in Agriculture in Latin America(all income levels) to that in Latin America(developing only)?
Offer a terse response. 0.91. What is the ratio of the Employment (as % of male employment) in Industry in Latin America(all income levels) to that in Latin America(developing only)?
Provide a short and direct response. 1.03. What is the ratio of the Employment (as % of male employment) in Services in Latin America(all income levels) to that in Latin America(developing only)?
Your answer should be compact. 1.03. What is the ratio of the Employment (as % of male employment) in Self-employed in Latin America(all income levels) to that in Latin America(developing only)?
Offer a very short reply. 0.91. What is the difference between the highest and the second highest Employment (as % of male employment) in Agriculture?
Your answer should be very brief. 2.18. What is the difference between the highest and the second highest Employment (as % of male employment) in Industry?
Your answer should be very brief. 0.35. What is the difference between the highest and the second highest Employment (as % of male employment) in Services?
Provide a succinct answer. 0.35. What is the difference between the highest and the second highest Employment (as % of male employment) of Self-employed?
Offer a terse response. 0.79. What is the difference between the highest and the lowest Employment (as % of male employment) in Agriculture?
Provide a succinct answer. 17.86. What is the difference between the highest and the lowest Employment (as % of male employment) of Industry?
Your answer should be compact. 13.22. What is the difference between the highest and the lowest Employment (as % of male employment) of Services?
Make the answer very short. 7.82. What is the difference between the highest and the lowest Employment (as % of male employment) in Self-employed?
Provide a short and direct response. 5.67. 